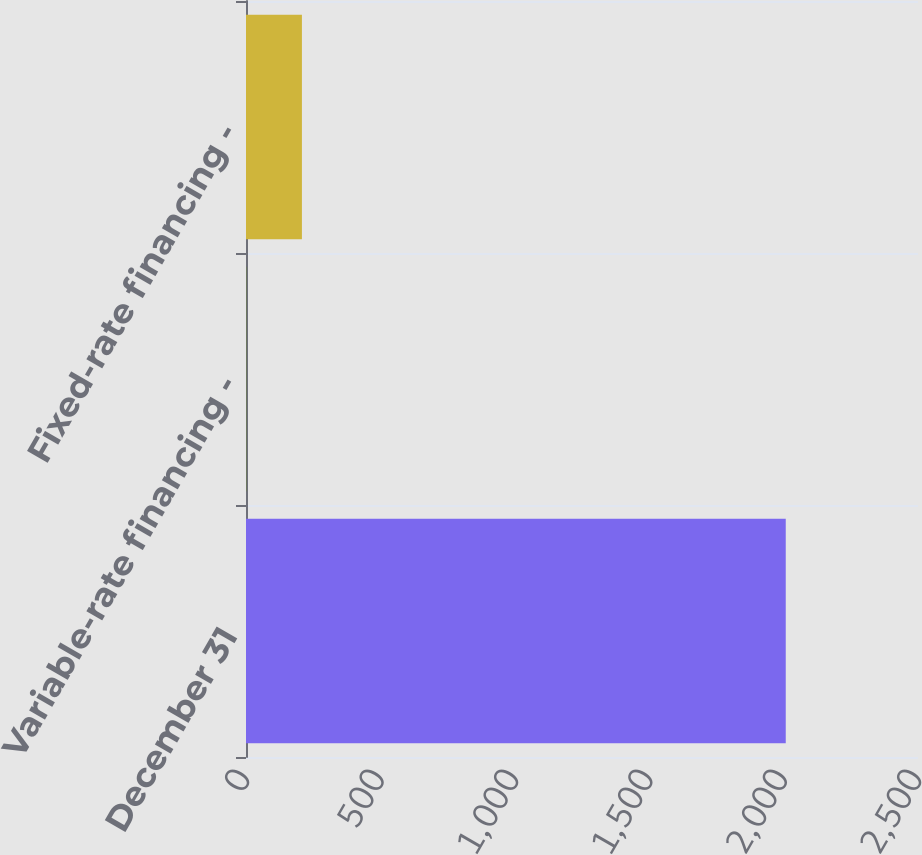<chart> <loc_0><loc_0><loc_500><loc_500><bar_chart><fcel>December 31<fcel>Variable-rate financing -<fcel>Fixed-rate financing -<nl><fcel>2008<fcel>1<fcel>208<nl></chart> 